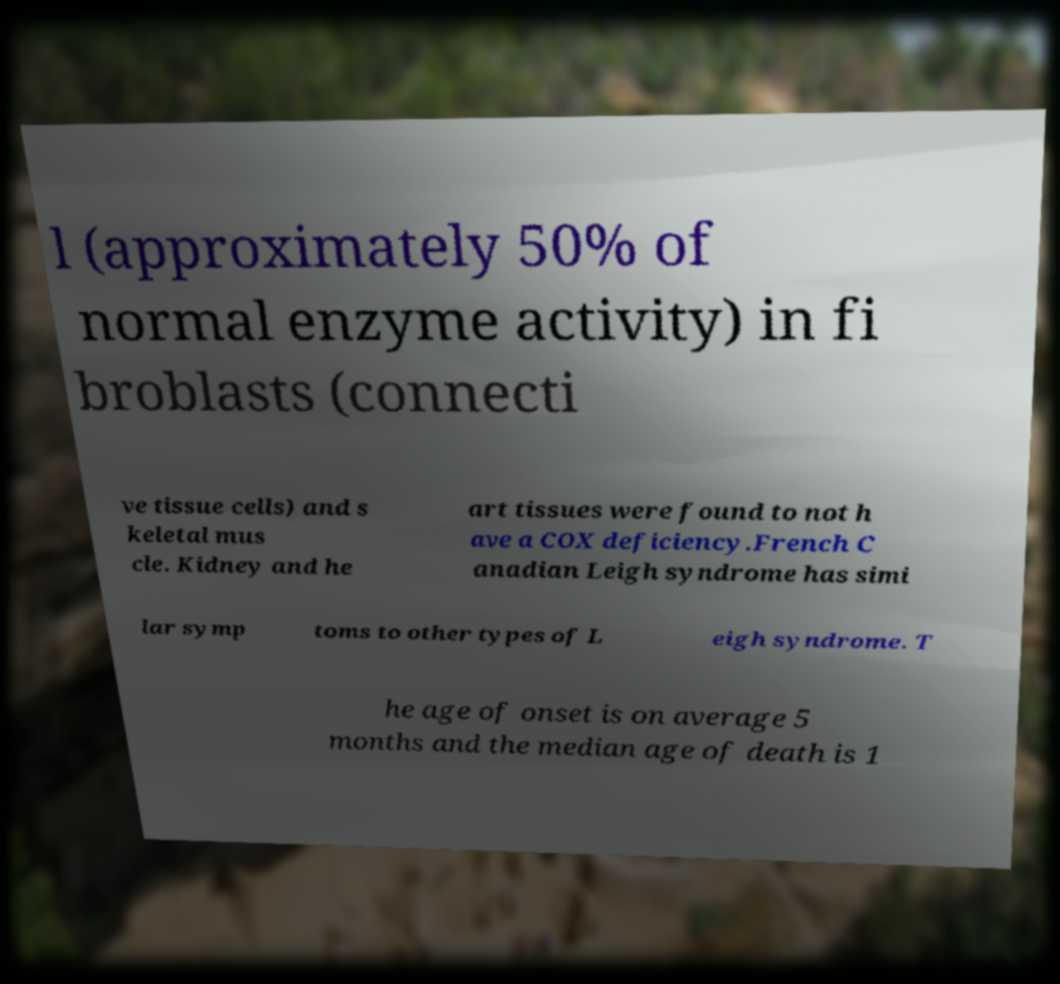I need the written content from this picture converted into text. Can you do that? l (approximately 50% of normal enzyme activity) in fi broblasts (connecti ve tissue cells) and s keletal mus cle. Kidney and he art tissues were found to not h ave a COX deficiency.French C anadian Leigh syndrome has simi lar symp toms to other types of L eigh syndrome. T he age of onset is on average 5 months and the median age of death is 1 